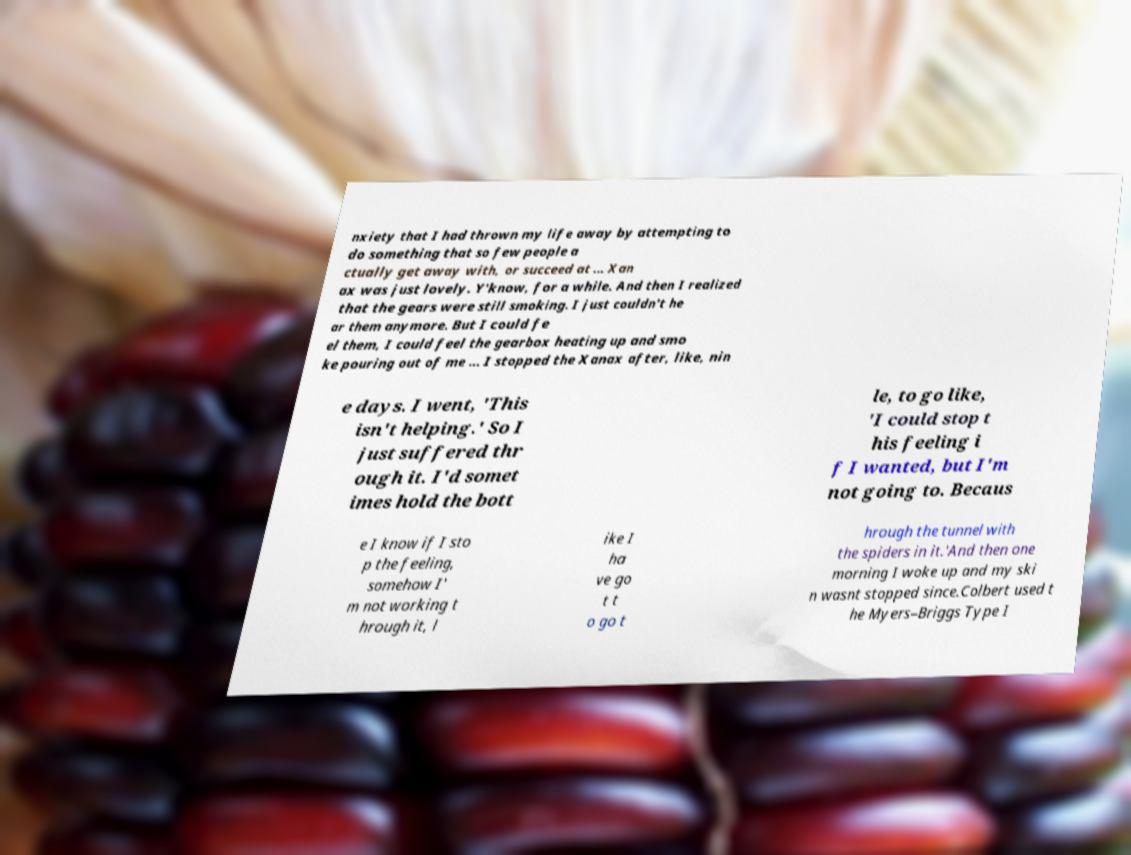I need the written content from this picture converted into text. Can you do that? nxiety that I had thrown my life away by attempting to do something that so few people a ctually get away with, or succeed at ... Xan ax was just lovely. Y'know, for a while. And then I realized that the gears were still smoking. I just couldn't he ar them anymore. But I could fe el them, I could feel the gearbox heating up and smo ke pouring out of me ... I stopped the Xanax after, like, nin e days. I went, 'This isn't helping.' So I just suffered thr ough it. I'd somet imes hold the bott le, to go like, 'I could stop t his feeling i f I wanted, but I'm not going to. Becaus e I know if I sto p the feeling, somehow I' m not working t hrough it, l ike I ha ve go t t o go t hrough the tunnel with the spiders in it.'And then one morning I woke up and my ski n wasnt stopped since.Colbert used t he Myers–Briggs Type I 